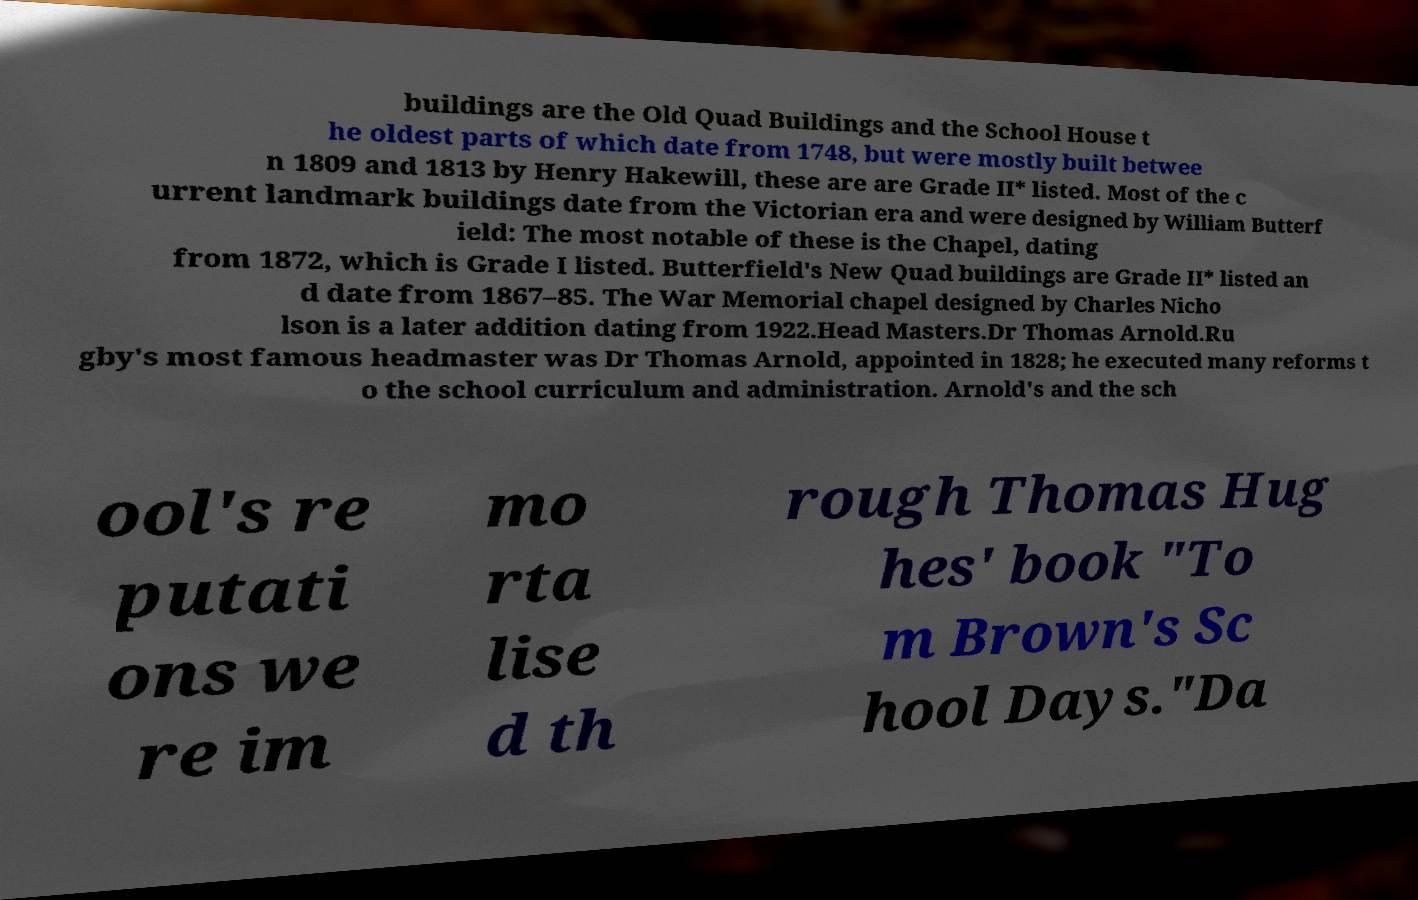Can you accurately transcribe the text from the provided image for me? buildings are the Old Quad Buildings and the School House t he oldest parts of which date from 1748, but were mostly built betwee n 1809 and 1813 by Henry Hakewill, these are are Grade II* listed. Most of the c urrent landmark buildings date from the Victorian era and were designed by William Butterf ield: The most notable of these is the Chapel, dating from 1872, which is Grade I listed. Butterfield's New Quad buildings are Grade II* listed an d date from 1867–85. The War Memorial chapel designed by Charles Nicho lson is a later addition dating from 1922.Head Masters.Dr Thomas Arnold.Ru gby's most famous headmaster was Dr Thomas Arnold, appointed in 1828; he executed many reforms t o the school curriculum and administration. Arnold's and the sch ool's re putati ons we re im mo rta lise d th rough Thomas Hug hes' book "To m Brown's Sc hool Days."Da 